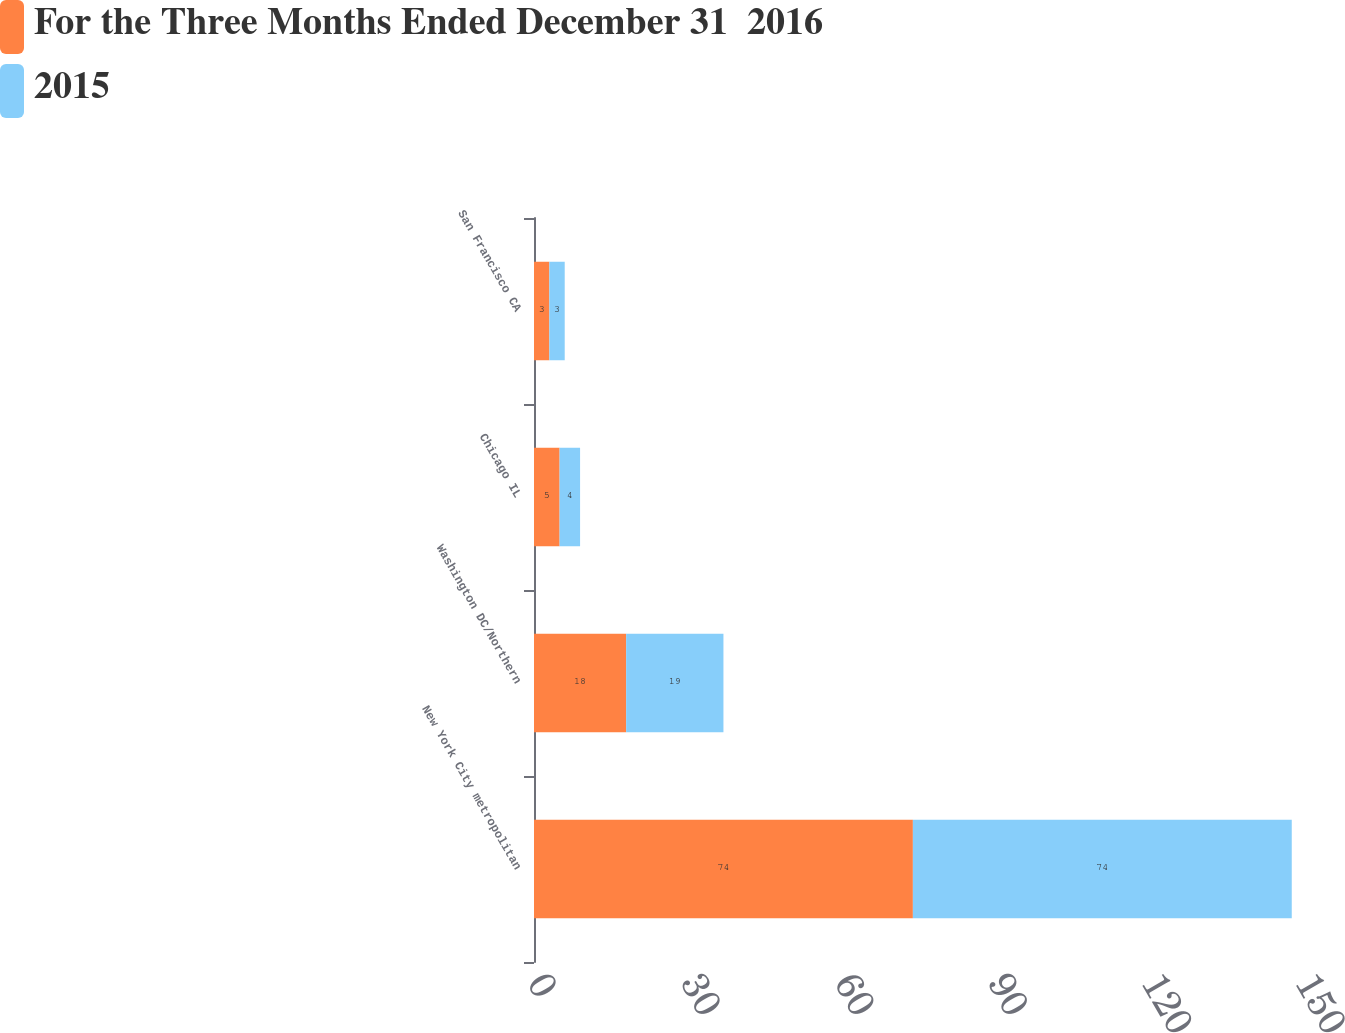<chart> <loc_0><loc_0><loc_500><loc_500><stacked_bar_chart><ecel><fcel>New York City metropolitan<fcel>Washington DC/Northern<fcel>Chicago IL<fcel>San Francisco CA<nl><fcel>For the Three Months Ended December 31  2016<fcel>74<fcel>18<fcel>5<fcel>3<nl><fcel>2015<fcel>74<fcel>19<fcel>4<fcel>3<nl></chart> 